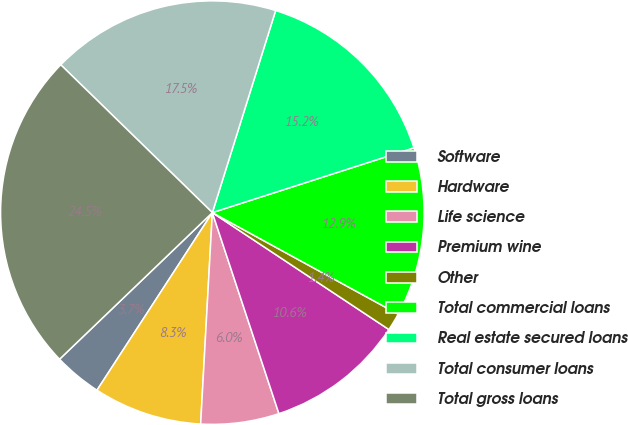<chart> <loc_0><loc_0><loc_500><loc_500><pie_chart><fcel>Software<fcel>Hardware<fcel>Life science<fcel>Premium wine<fcel>Other<fcel>Total commercial loans<fcel>Real estate secured loans<fcel>Total consumer loans<fcel>Total gross loans<nl><fcel>3.66%<fcel>8.29%<fcel>5.97%<fcel>10.6%<fcel>1.35%<fcel>12.91%<fcel>15.22%<fcel>17.53%<fcel>24.47%<nl></chart> 